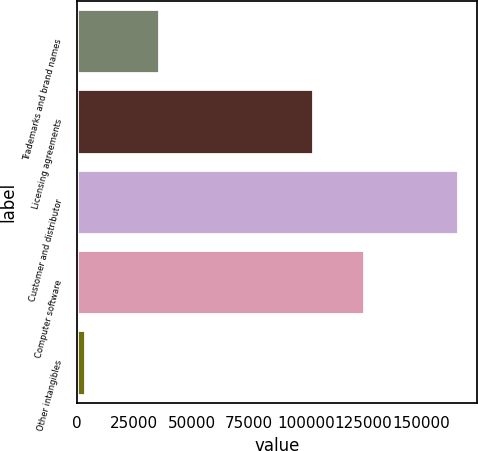Convert chart. <chart><loc_0><loc_0><loc_500><loc_500><bar_chart><fcel>Trademarks and brand names<fcel>Licensing agreements<fcel>Customer and distributor<fcel>Computer software<fcel>Other intangibles<nl><fcel>35818<fcel>102929<fcel>166176<fcel>125319<fcel>3343<nl></chart> 